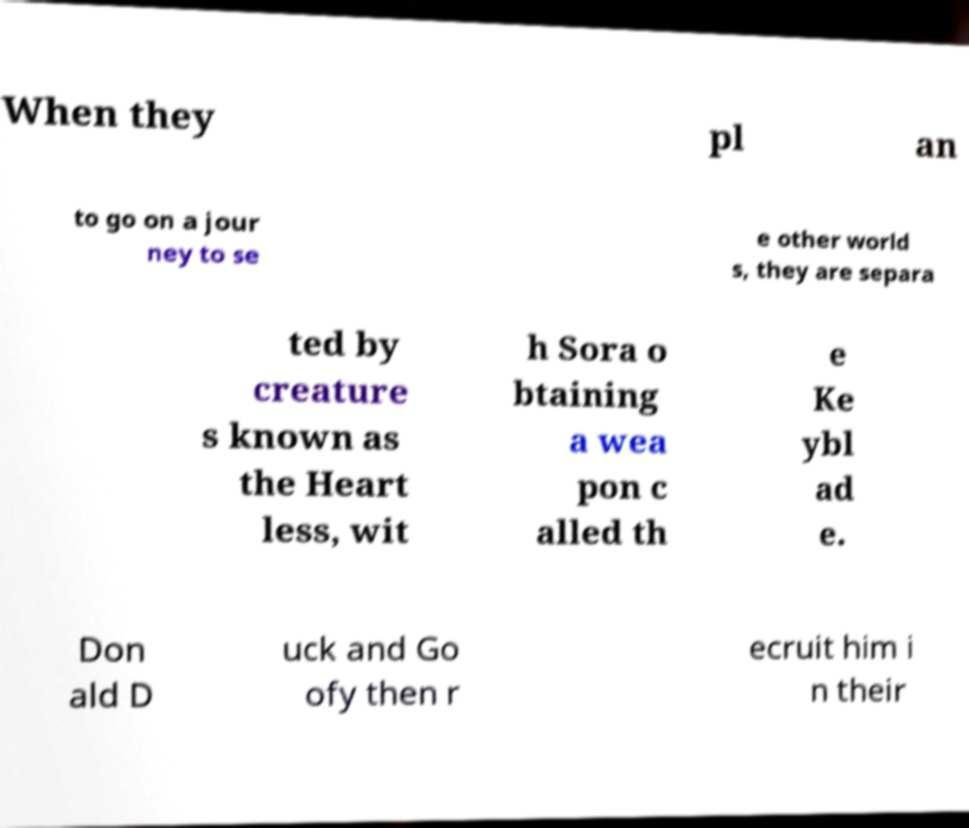Can you read and provide the text displayed in the image?This photo seems to have some interesting text. Can you extract and type it out for me? When they pl an to go on a jour ney to se e other world s, they are separa ted by creature s known as the Heart less, wit h Sora o btaining a wea pon c alled th e Ke ybl ad e. Don ald D uck and Go ofy then r ecruit him i n their 